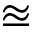Convert formula to latex. <formula><loc_0><loc_0><loc_500><loc_500>\approxeq</formula> 